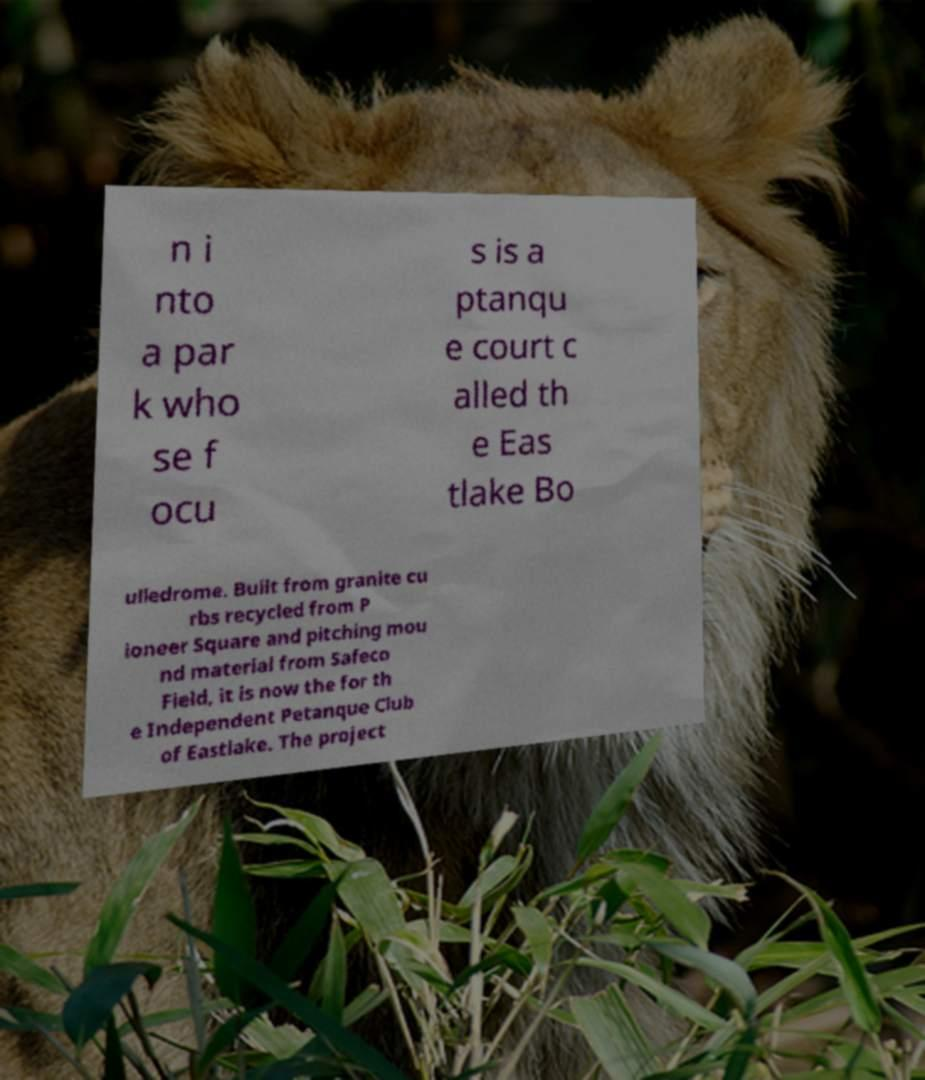Please read and relay the text visible in this image. What does it say? n i nto a par k who se f ocu s is a ptanqu e court c alled th e Eas tlake Bo ulledrome. Built from granite cu rbs recycled from P ioneer Square and pitching mou nd material from Safeco Field, it is now the for th e Independent Petanque Club of Eastlake. The project 